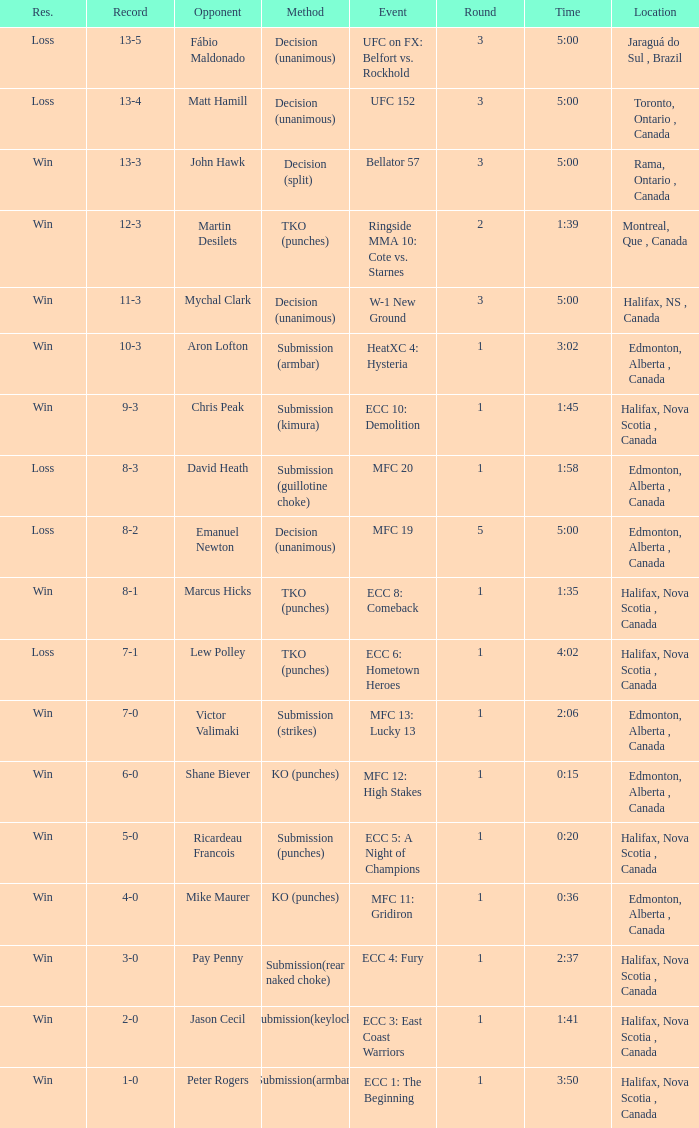Who is the opponent of the match with a win result and a time of 3:02? Aron Lofton. 